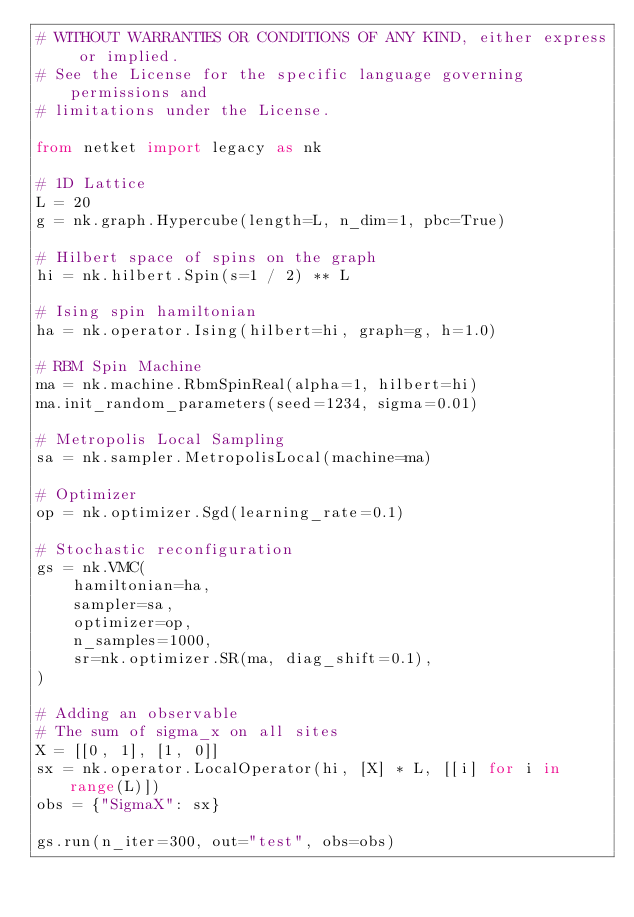Convert code to text. <code><loc_0><loc_0><loc_500><loc_500><_Python_># WITHOUT WARRANTIES OR CONDITIONS OF ANY KIND, either express or implied.
# See the License for the specific language governing permissions and
# limitations under the License.

from netket import legacy as nk

# 1D Lattice
L = 20
g = nk.graph.Hypercube(length=L, n_dim=1, pbc=True)

# Hilbert space of spins on the graph
hi = nk.hilbert.Spin(s=1 / 2) ** L

# Ising spin hamiltonian
ha = nk.operator.Ising(hilbert=hi, graph=g, h=1.0)

# RBM Spin Machine
ma = nk.machine.RbmSpinReal(alpha=1, hilbert=hi)
ma.init_random_parameters(seed=1234, sigma=0.01)

# Metropolis Local Sampling
sa = nk.sampler.MetropolisLocal(machine=ma)

# Optimizer
op = nk.optimizer.Sgd(learning_rate=0.1)

# Stochastic reconfiguration
gs = nk.VMC(
    hamiltonian=ha,
    sampler=sa,
    optimizer=op,
    n_samples=1000,
    sr=nk.optimizer.SR(ma, diag_shift=0.1),
)

# Adding an observable
# The sum of sigma_x on all sites
X = [[0, 1], [1, 0]]
sx = nk.operator.LocalOperator(hi, [X] * L, [[i] for i in range(L)])
obs = {"SigmaX": sx}

gs.run(n_iter=300, out="test", obs=obs)
</code> 